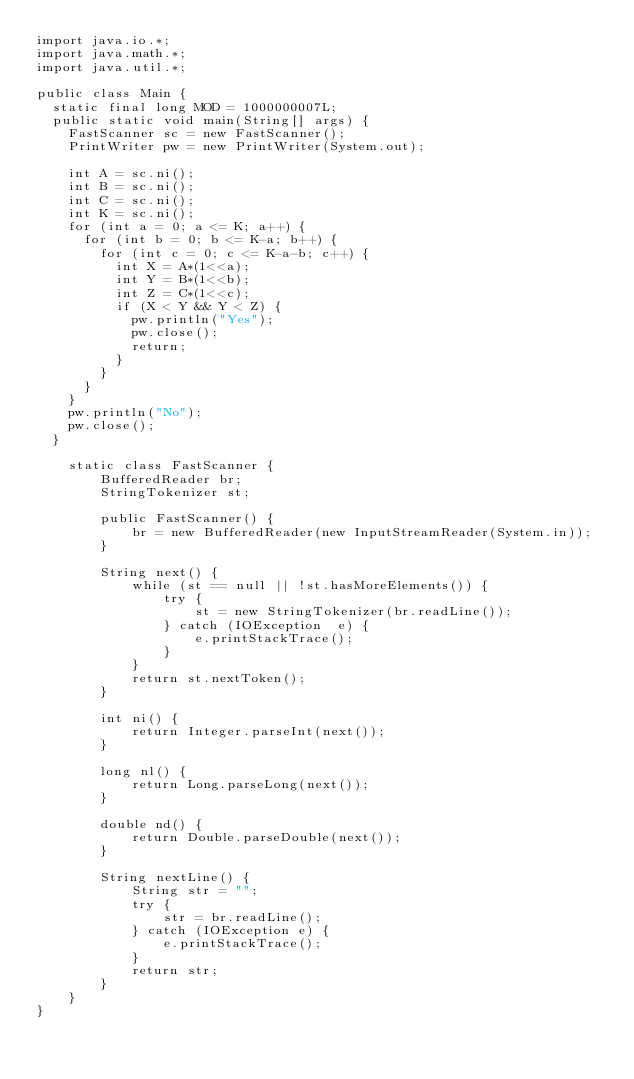Convert code to text. <code><loc_0><loc_0><loc_500><loc_500><_Java_>import java.io.*;
import java.math.*;
import java.util.*;
 
public class Main {
	static final long MOD = 1000000007L;
	public static void main(String[] args) {
		FastScanner sc = new FastScanner();
		PrintWriter pw = new PrintWriter(System.out);
		
		int A = sc.ni();
		int B = sc.ni();
		int C = sc.ni();
		int K = sc.ni();
		for (int a = 0; a <= K; a++) {
			for (int b = 0; b <= K-a; b++) {
				for (int c = 0; c <= K-a-b; c++) {
					int X = A*(1<<a);
					int Y = B*(1<<b);
					int Z = C*(1<<c);
					if (X < Y && Y < Z) {
						pw.println("Yes");
						pw.close();
						return;
					}
				}
			}
		}
		pw.println("No");
		pw.close();
	}
	
    static class FastScanner { 
        BufferedReader br; 
        StringTokenizer st; 
  
        public FastScanner() { 
            br = new BufferedReader(new InputStreamReader(System.in)); 
        } 
  
        String next() { 
            while (st == null || !st.hasMoreElements()) { 
                try { 
                    st = new StringTokenizer(br.readLine());
                } catch (IOException  e) { 
                    e.printStackTrace(); 
                } 
            } 
            return st.nextToken(); 
        }
        
        int ni() { 
            return Integer.parseInt(next()); 
        }
  
        long nl() { 
            return Long.parseLong(next()); 
        } 
  
        double nd() { 
            return Double.parseDouble(next()); 
        } 
  
        String nextLine() {
            String str = ""; 
            try { 
                str = br.readLine(); 
            } catch (IOException e) {
                e.printStackTrace(); 
            } 
            return str;
        }
    }
}</code> 